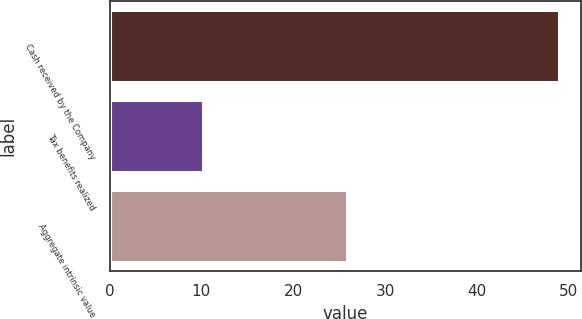<chart> <loc_0><loc_0><loc_500><loc_500><bar_chart><fcel>Cash received by the Company<fcel>Tax benefits realized<fcel>Aggregate intrinsic value<nl><fcel>48.9<fcel>10.2<fcel>25.8<nl></chart> 